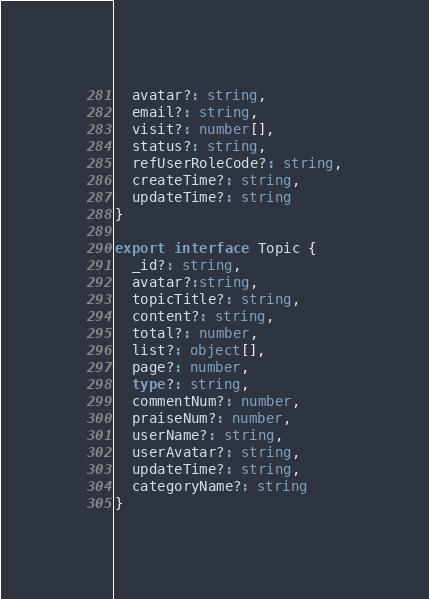<code> <loc_0><loc_0><loc_500><loc_500><_TypeScript_>  avatar?: string,
  email?: string,
  visit?: number[],
  status?: string,
  refUserRoleCode?: string,
  createTime?: string,
  updateTime?: string
}

export interface Topic {
  _id?: string,
  avatar?:string,
  topicTitle?: string,
  content?: string,
  total?: number,
  list?: object[],
  page?: number,
  type?: string,
  commentNum?: number,
  praiseNum?: number,
  userName?: string,
  userAvatar?: string,
  updateTime?: string,
  categoryName?: string
}</code> 